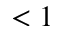Convert formula to latex. <formula><loc_0><loc_0><loc_500><loc_500>< 1</formula> 